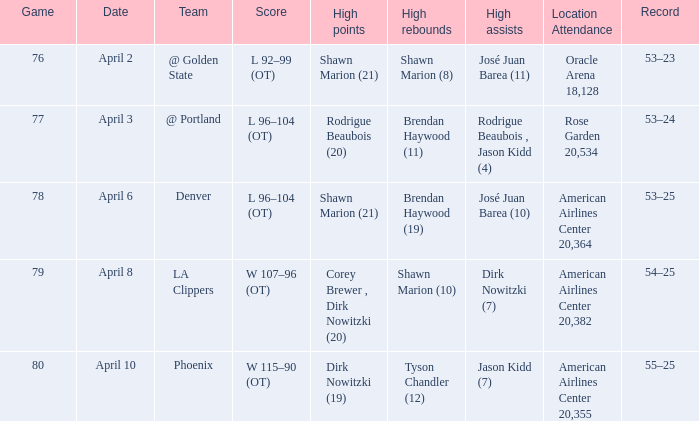What is the record after the Phoenix game? 55–25. 